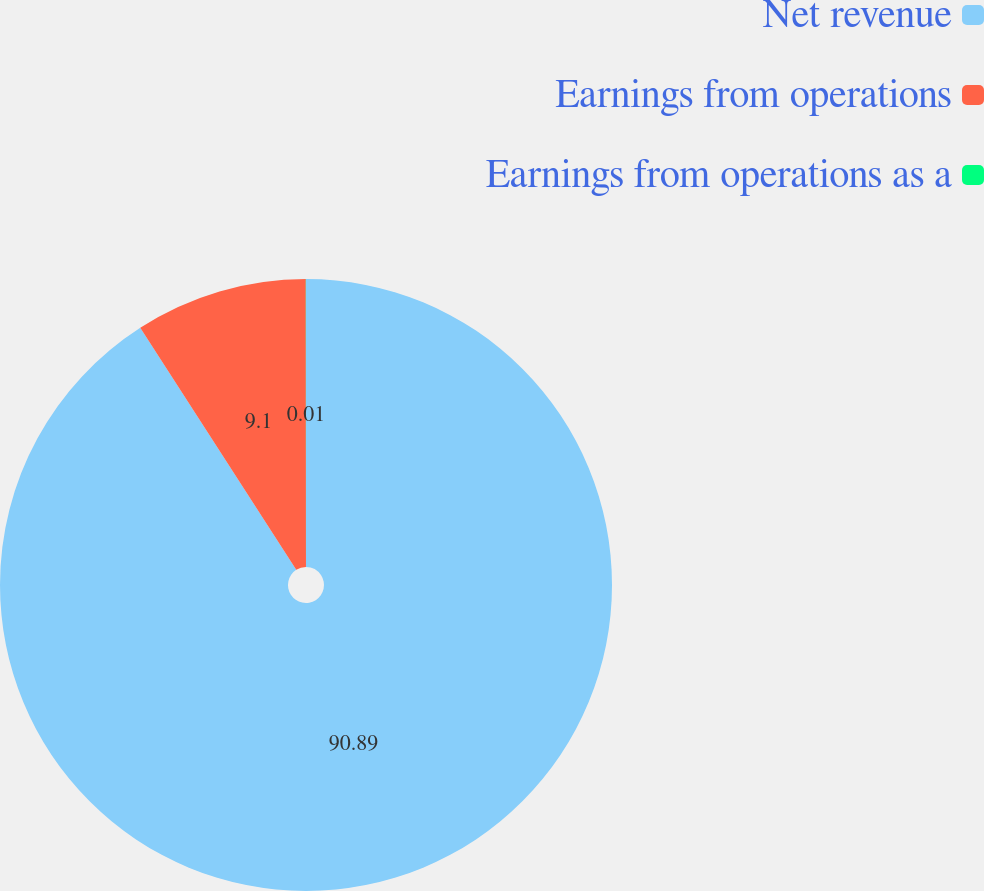Convert chart. <chart><loc_0><loc_0><loc_500><loc_500><pie_chart><fcel>Net revenue<fcel>Earnings from operations<fcel>Earnings from operations as a<nl><fcel>90.89%<fcel>9.1%<fcel>0.01%<nl></chart> 